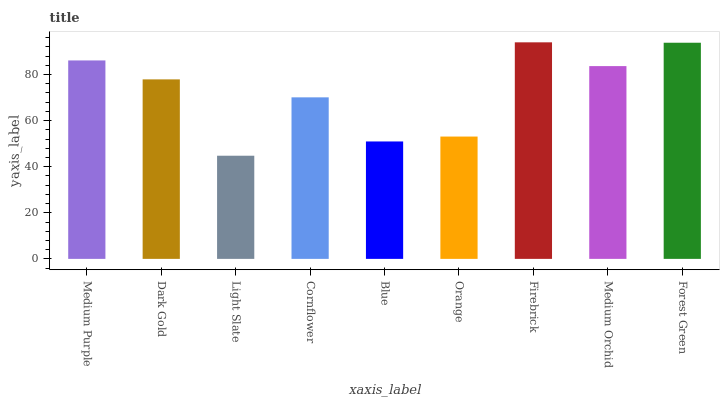Is Dark Gold the minimum?
Answer yes or no. No. Is Dark Gold the maximum?
Answer yes or no. No. Is Medium Purple greater than Dark Gold?
Answer yes or no. Yes. Is Dark Gold less than Medium Purple?
Answer yes or no. Yes. Is Dark Gold greater than Medium Purple?
Answer yes or no. No. Is Medium Purple less than Dark Gold?
Answer yes or no. No. Is Dark Gold the high median?
Answer yes or no. Yes. Is Dark Gold the low median?
Answer yes or no. Yes. Is Orange the high median?
Answer yes or no. No. Is Medium Purple the low median?
Answer yes or no. No. 